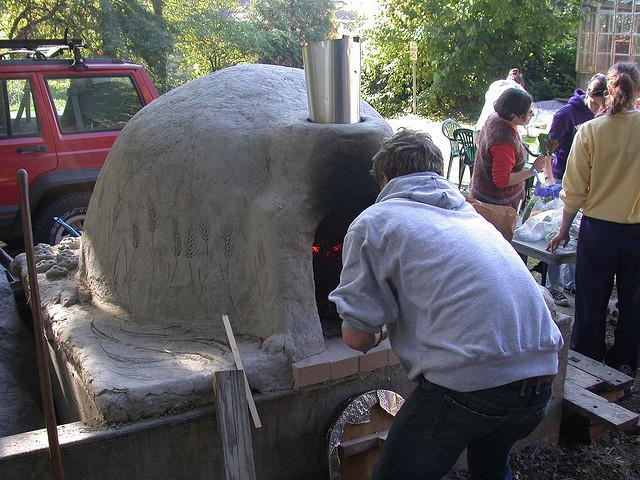In what location was this oven built? Please explain your reasoning. here. The oven is stuck in place. 